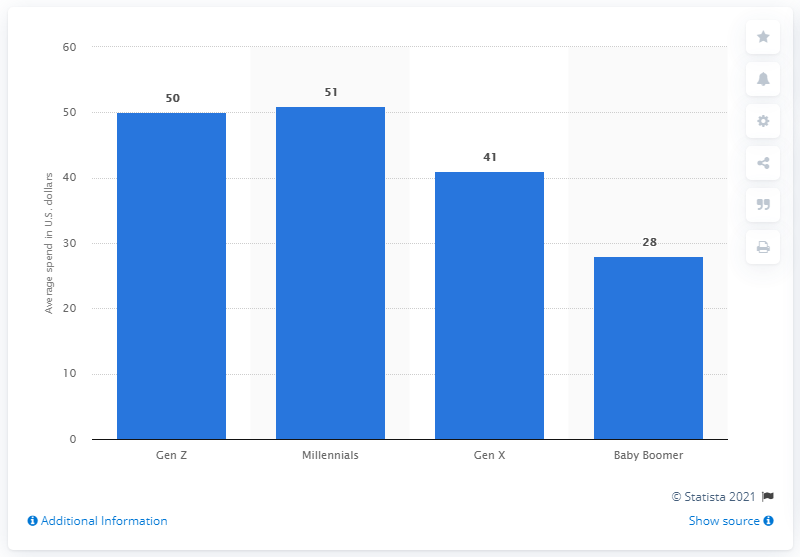How many dollars did Millennials plan to spend on their pets on average during the holiday season?
 51 